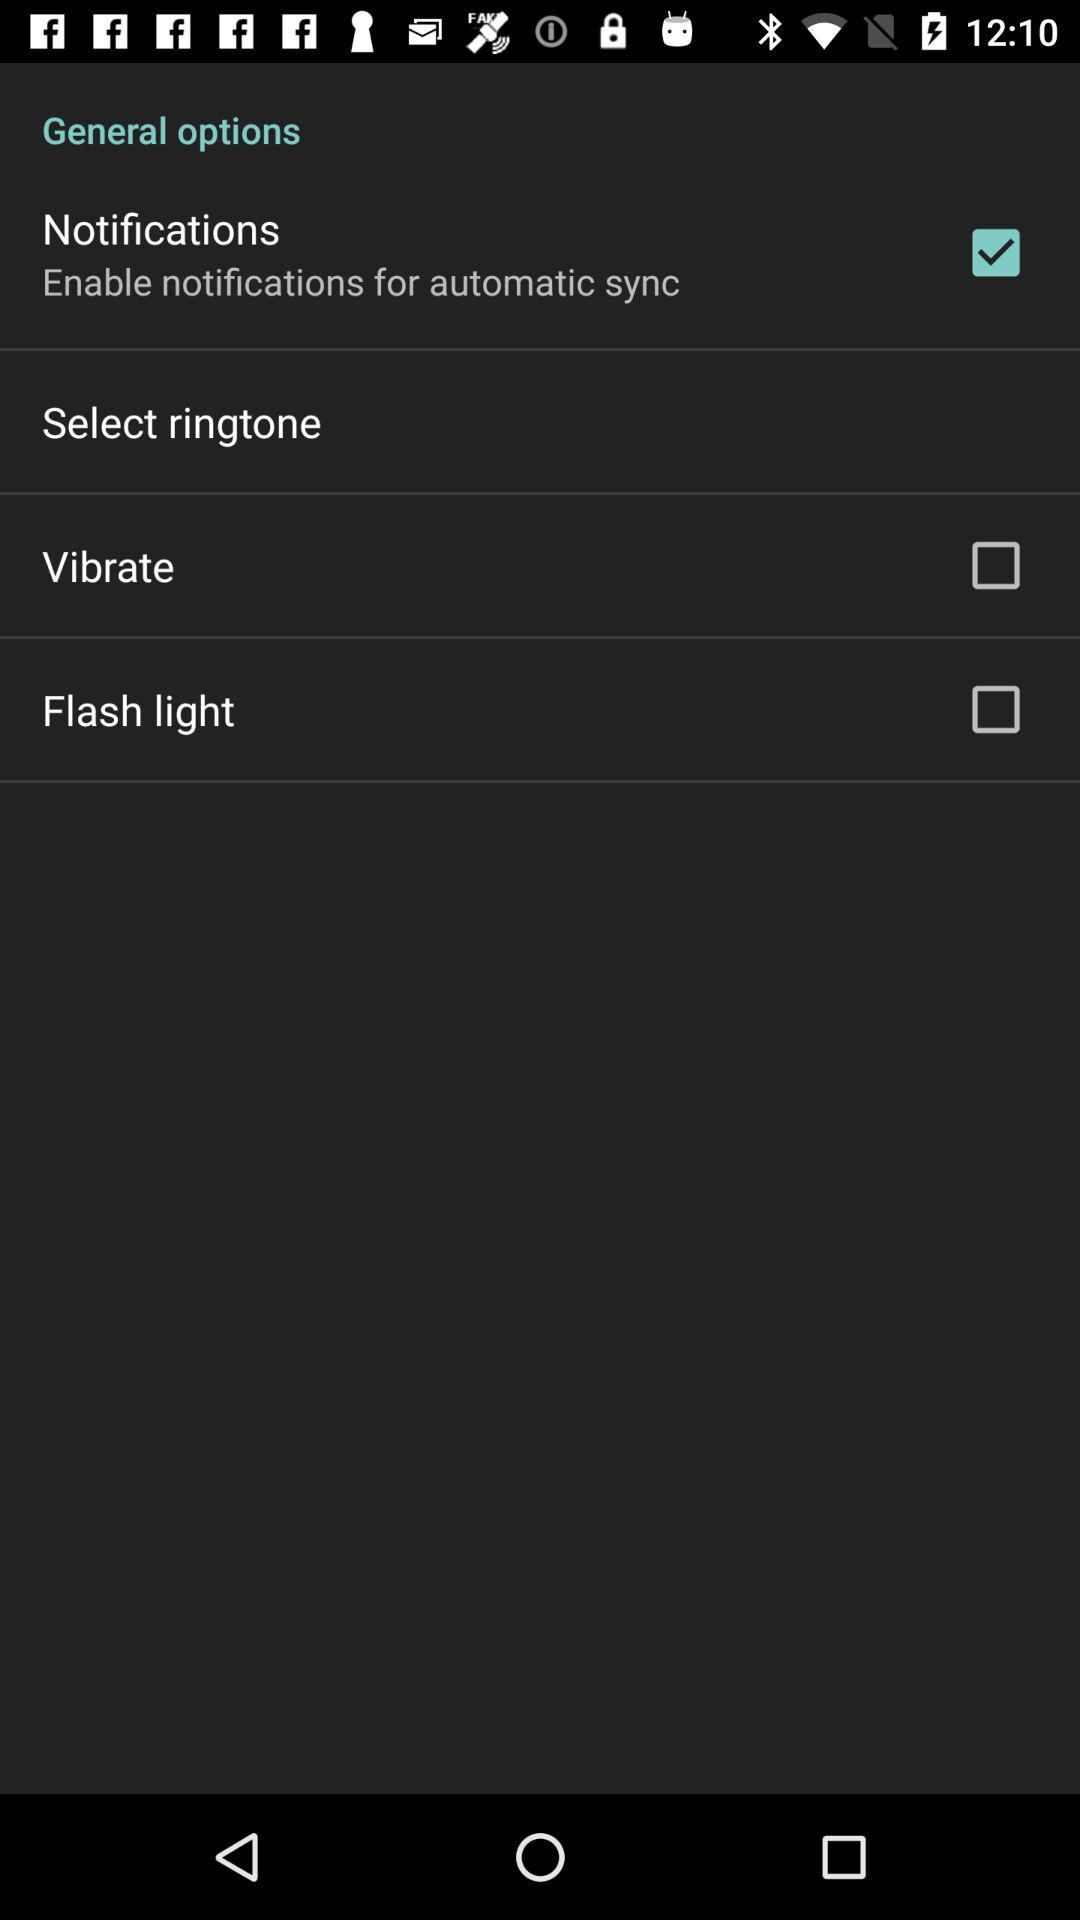What is the status of the vibrate and flash light? The status of the vibrate and flash light is off. 